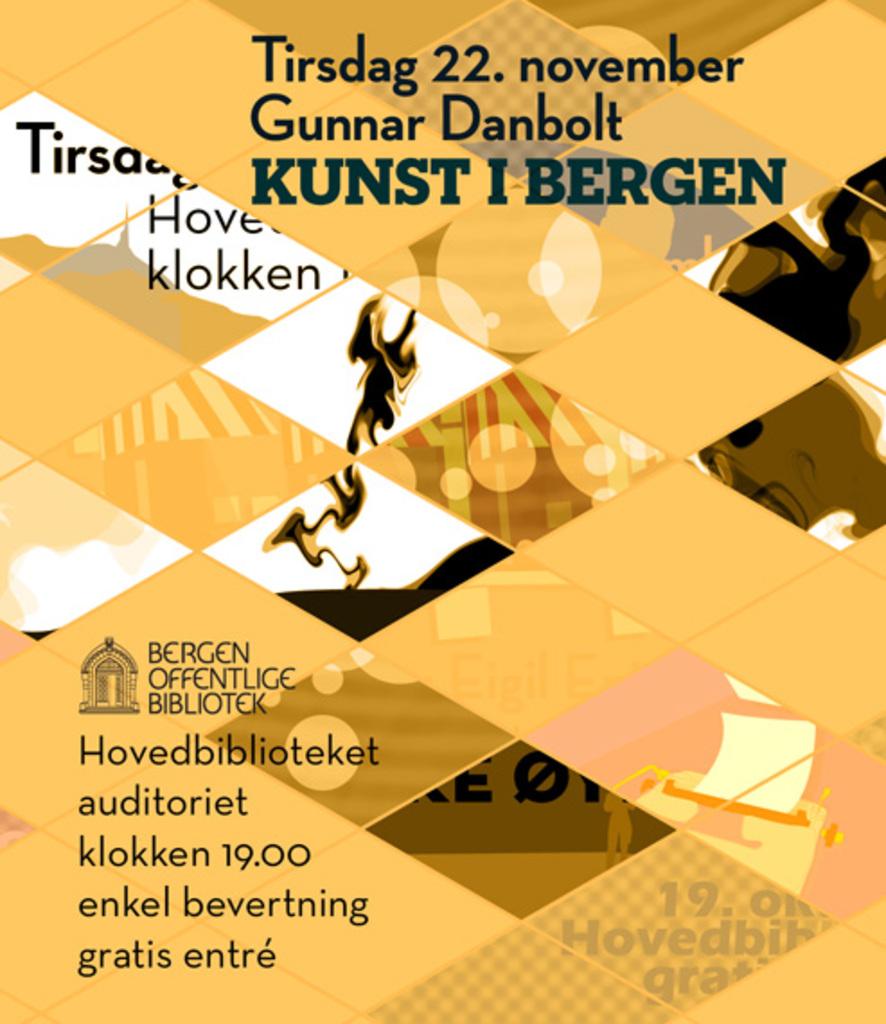What date is this?
Your answer should be compact. November 22. 